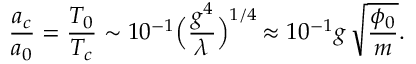<formula> <loc_0><loc_0><loc_500><loc_500>{ \frac { a _ { c } } { a _ { 0 } } } = { \frac { T _ { 0 } } { T _ { c } } } \sim 1 0 ^ { - 1 } \left ( { \frac { g ^ { 4 } } { \lambda } } \right ) ^ { 1 / 4 } \, \approx 1 0 ^ { - 1 } g \, \sqrt { \frac { \phi _ { 0 } } { m } } .</formula> 